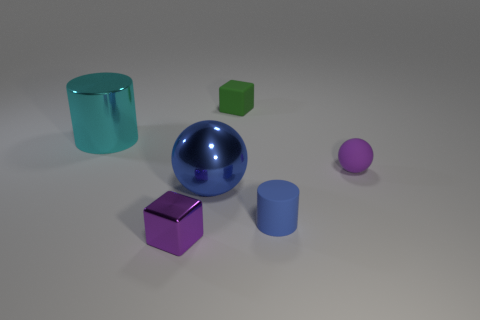How many other things are there of the same color as the big metal cylinder?
Give a very brief answer. 0. There is a rubber thing that is in front of the ball to the left of the small green thing; what is its color?
Provide a succinct answer. Blue. Is there another sphere that has the same color as the large sphere?
Give a very brief answer. No. What number of matte objects are either big things or purple cylinders?
Keep it short and to the point. 0. Are there any purple blocks that have the same material as the tiny green object?
Provide a succinct answer. No. What number of things are both behind the tiny blue matte cylinder and on the right side of the small metal thing?
Provide a succinct answer. 3. Is the number of big blue objects that are behind the purple matte ball less than the number of cyan shiny cylinders that are in front of the blue cylinder?
Ensure brevity in your answer.  No. Is the purple metallic object the same shape as the cyan shiny object?
Ensure brevity in your answer.  No. What number of other objects are there of the same size as the blue rubber thing?
Offer a very short reply. 3. What number of objects are blue things in front of the blue metal ball or big metal things that are in front of the big cyan object?
Offer a terse response. 2. 